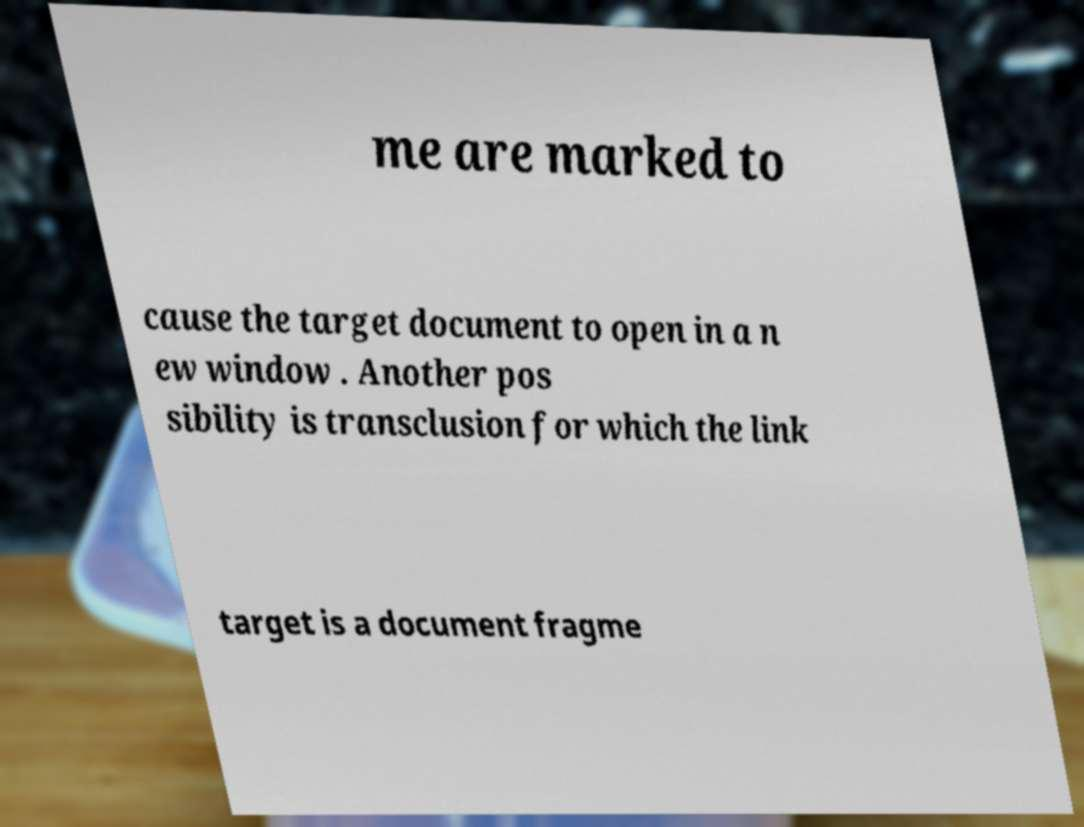I need the written content from this picture converted into text. Can you do that? me are marked to cause the target document to open in a n ew window . Another pos sibility is transclusion for which the link target is a document fragme 